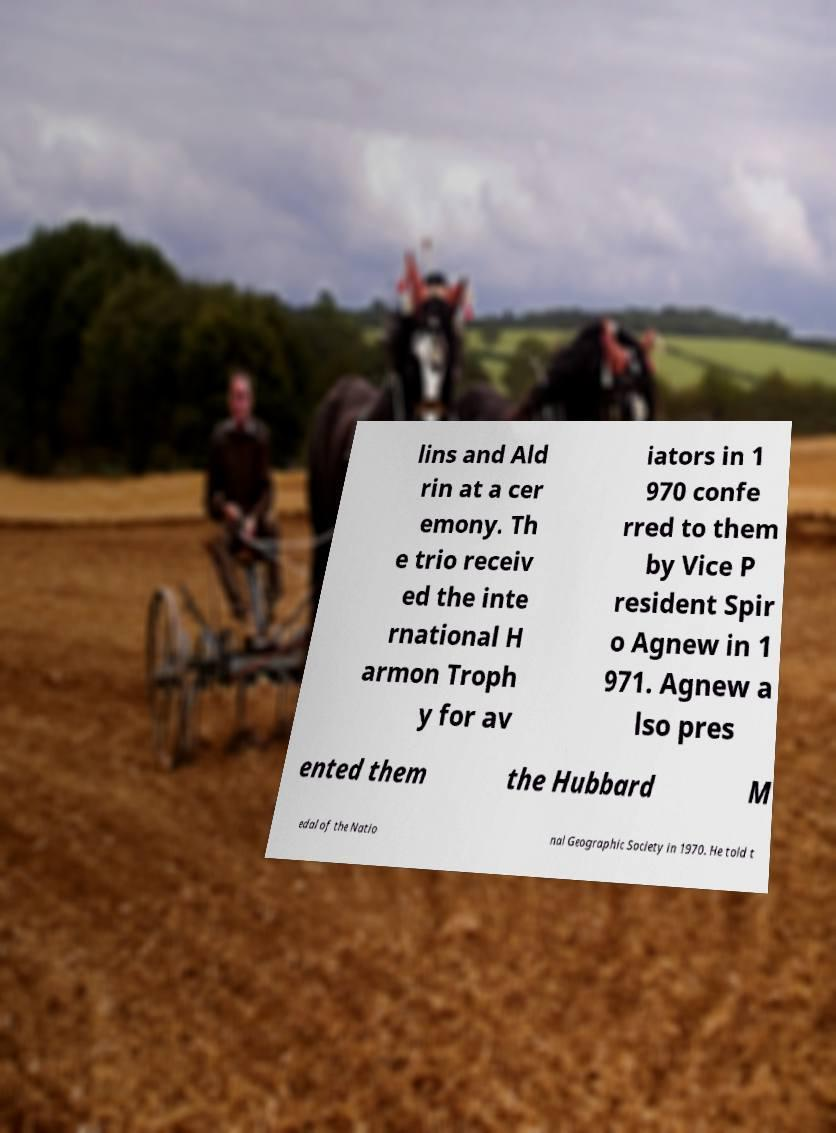Could you assist in decoding the text presented in this image and type it out clearly? lins and Ald rin at a cer emony. Th e trio receiv ed the inte rnational H armon Troph y for av iators in 1 970 confe rred to them by Vice P resident Spir o Agnew in 1 971. Agnew a lso pres ented them the Hubbard M edal of the Natio nal Geographic Society in 1970. He told t 